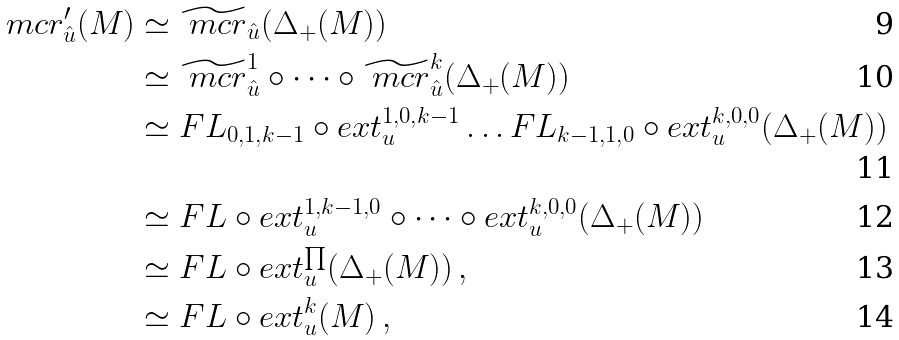<formula> <loc_0><loc_0><loc_500><loc_500>\ m c r ^ { \prime } _ { \hat { u } } ( M ) & \simeq \widetilde { \ m c r } _ { \hat { u } } ( \Delta _ { + } ( M ) ) \\ & \simeq \widetilde { \ m c r } ^ { 1 } _ { \hat { u } } \circ \dots \circ \widetilde { \ m c r } ^ { k } _ { \hat { u } } ( \Delta _ { + } ( M ) ) \\ & \simeq F L _ { 0 , 1 , k - 1 } \circ e x t _ { u } ^ { 1 , 0 , k - 1 } \dots F L _ { k - 1 , 1 , 0 } \circ e x t _ { u } ^ { k , 0 , 0 } ( \Delta _ { + } ( M ) ) \\ & \simeq F L \circ e x t _ { u } ^ { 1 , k - 1 , 0 } \circ \dots \circ e x t _ { u } ^ { k , 0 , 0 } ( \Delta _ { + } ( M ) ) \\ & \simeq F L \circ e x t ^ { \prod } _ { u } ( \Delta _ { + } ( M ) ) \, , \\ & \simeq F L \circ e x t ^ { k } _ { u } ( M ) \, ,</formula> 